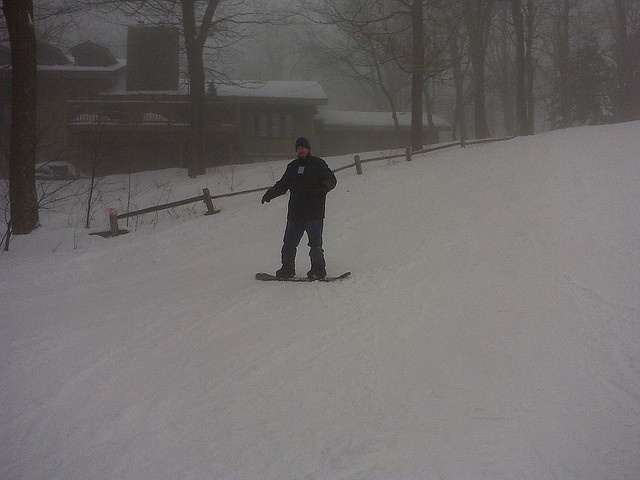Describe the objects in this image and their specific colors. I can see people in black and gray tones and snowboard in black and gray tones in this image. 